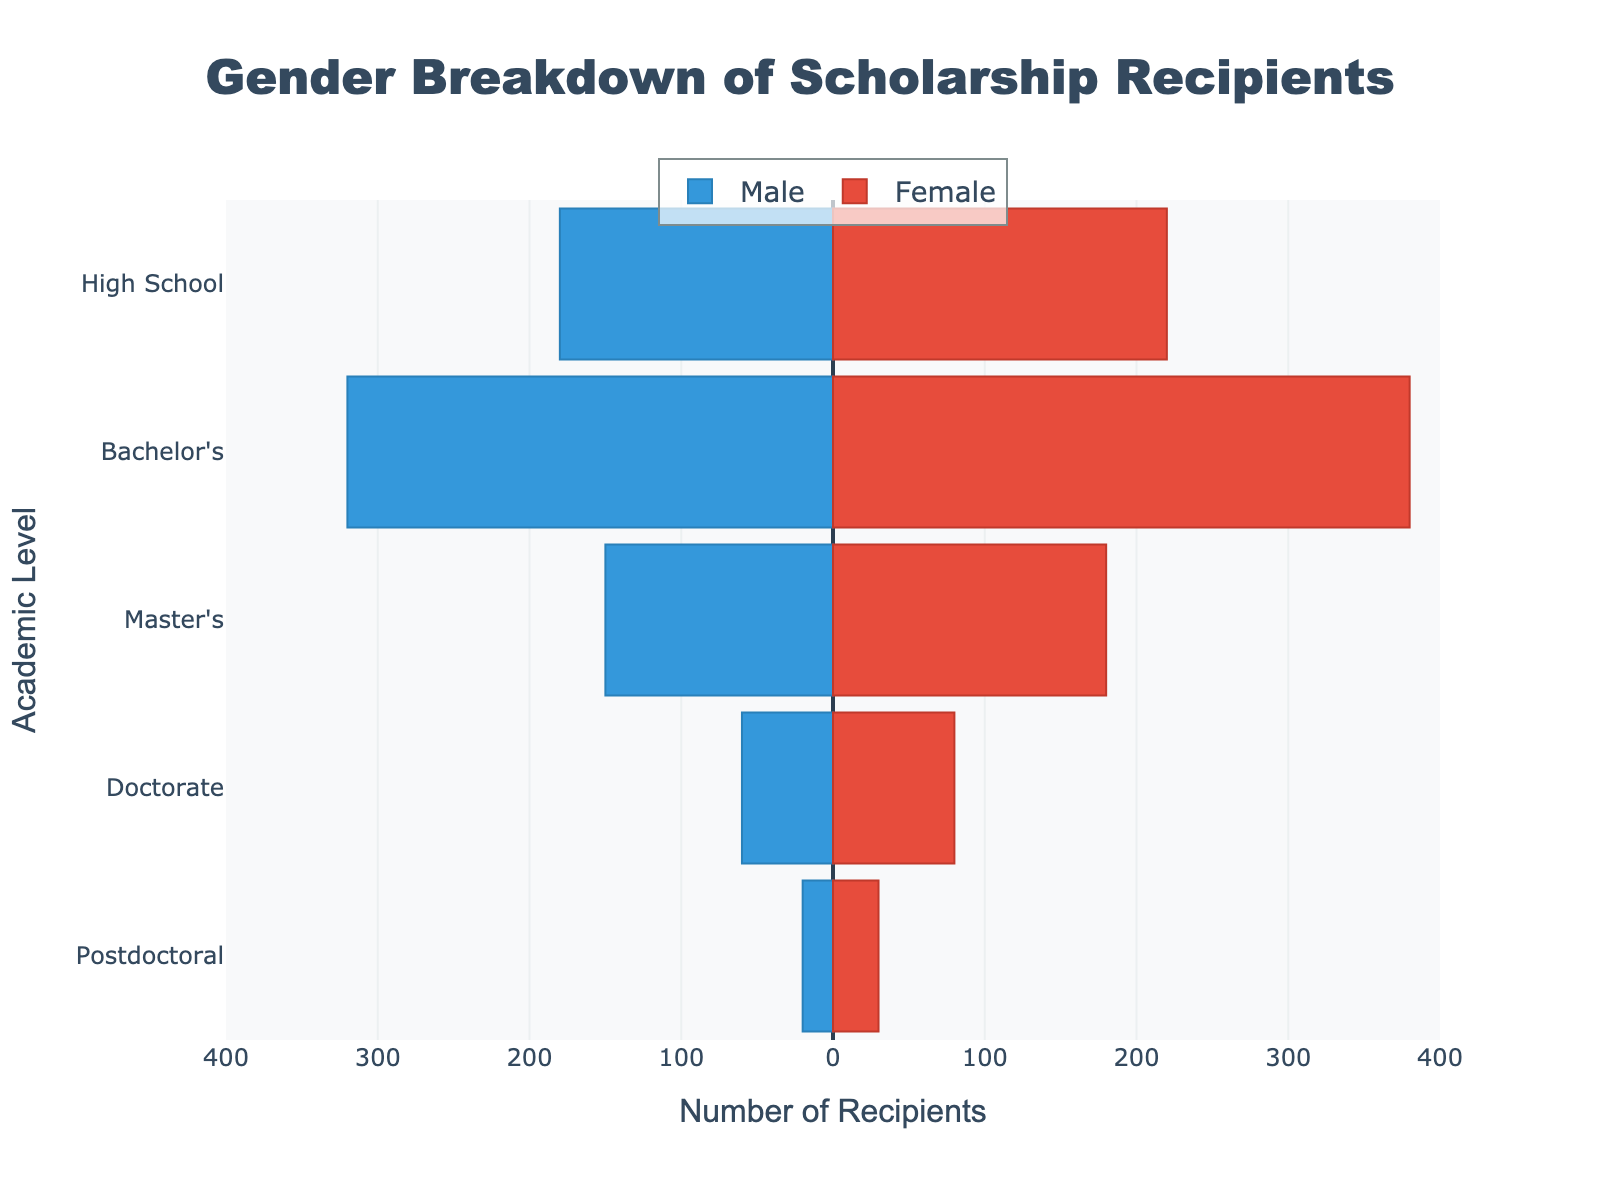Who has the highest number of scholarship recipients, males or females, at the Bachelor's level? Look at the bars for the Bachelor's level. The Male bar extends to -320, and the Female bar extends to 380. Since 380 is greater than 320, females have the highest number of scholarship recipients at this level.
Answer: Females What's the total number of scholarship recipients at the Master's level? Add the number of males and females at the Master's level. From the plot, males are 150 and females are 180. So, the total is 150 + 180 = 330.
Answer: 330 What is the percentage of female scholarship recipients at the Doctorate level? First, calculate the total number of recipients at the Doctorate level: 60 males + 80 females = 140 total. The percentage of females is (80/140) * 100 ≈ 57.14%.
Answer: 57.14% Is there any academic level where the number of male recipients exceeds the number of female recipients? Compare the male and female bars at each academic level. There is no level where the male bar extends further than the female bar.
Answer: No What's the average number of scholarship recipients for the male category across all academic levels? Sum up the numbers for males across all levels and divide by the number of levels. (180 + 320 + 150 + 60 + 20) / 5 = 730 / 5 = 146.
Answer: 146 Which academic level has the most balanced gender representation? Calculate the relative numbers (the difference) for each level. High School: 180/220 ≈ 0.82, Bachelor's: 320/380 ≈ 0.84, Master's: 150/180 ≈ 0.83, Doctorate: 60/80 ≈ 0.75, Postdoctoral: 20/30 ≈ 0.67. The level closest to 1 is the Bachelor's level (0.84).
Answer: Bachelor's What is the total number of scholarship recipients across all academic levels? Sum up the male and female recipients at each level and then add these sums: High School (180 + 220) + Bachelor's (320 + 380) + Master's (150 + 180) + Doctorate (60 + 80) + Postdoctoral (20 + 30) = 400 + 700 + 330 + 140 + 50 = 1620.
Answer: 1620 